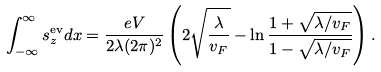Convert formula to latex. <formula><loc_0><loc_0><loc_500><loc_500>\int _ { - \infty } ^ { \infty } s _ { z } ^ { \text {ev} } d x = \frac { e V } { 2 \lambda ( 2 \pi ) ^ { 2 } } \left ( 2 \sqrt { \frac { \lambda } { v _ { F } } } - \ln { \frac { 1 + \sqrt { \lambda / v _ { F } } } { 1 - \sqrt { \lambda / v _ { F } } } } \right ) .</formula> 